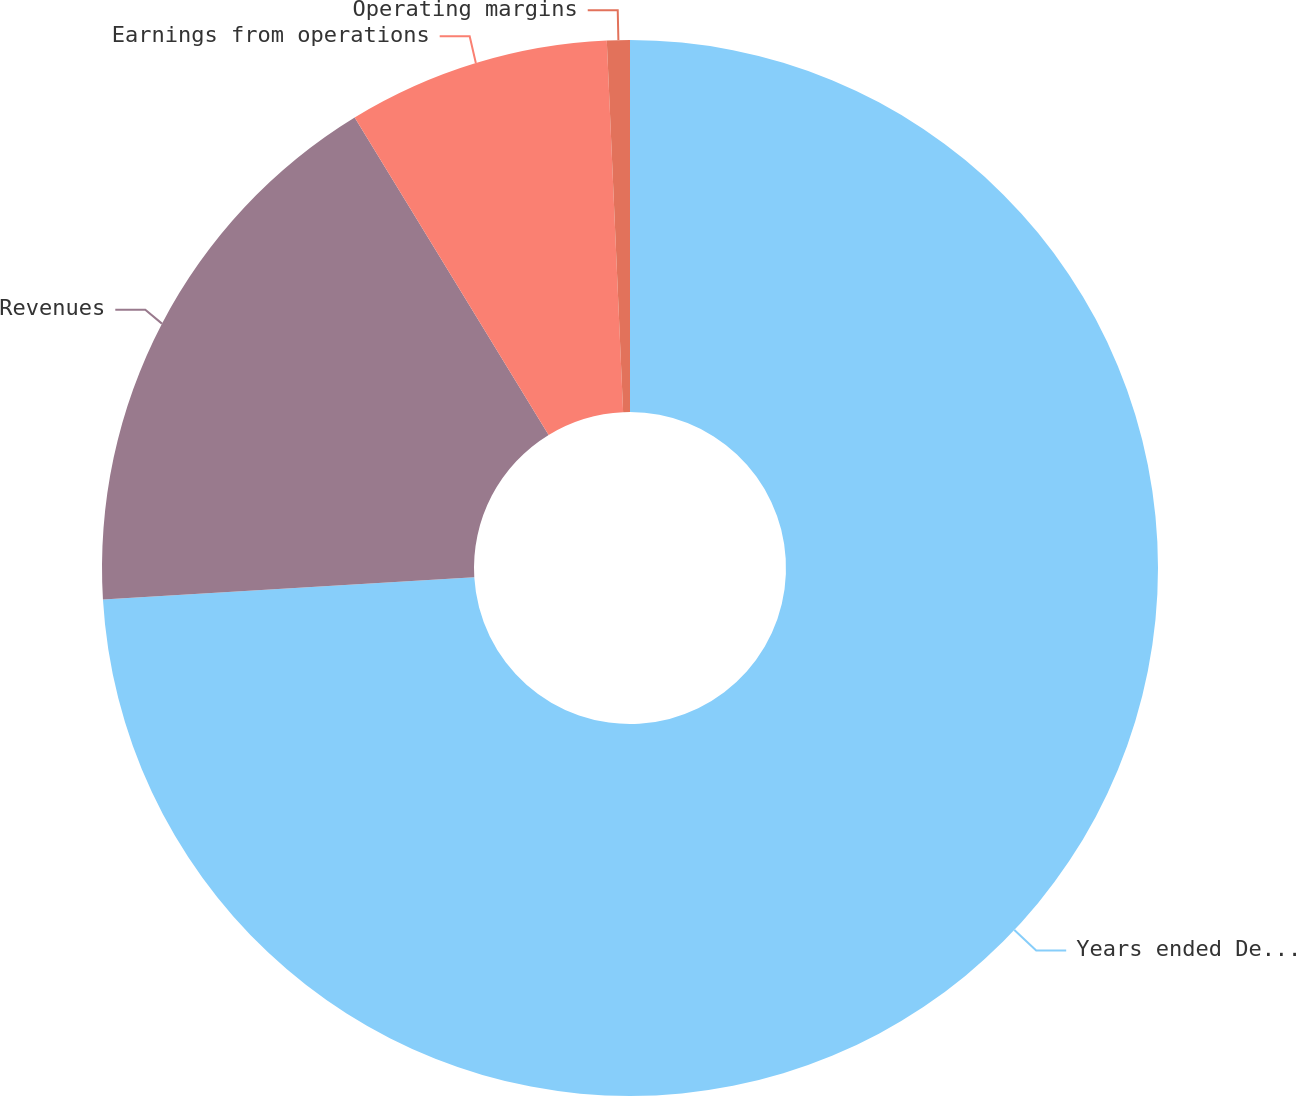<chart> <loc_0><loc_0><loc_500><loc_500><pie_chart><fcel>Years ended December 31<fcel>Revenues<fcel>Earnings from operations<fcel>Operating margins<nl><fcel>74.04%<fcel>17.22%<fcel>8.03%<fcel>0.7%<nl></chart> 